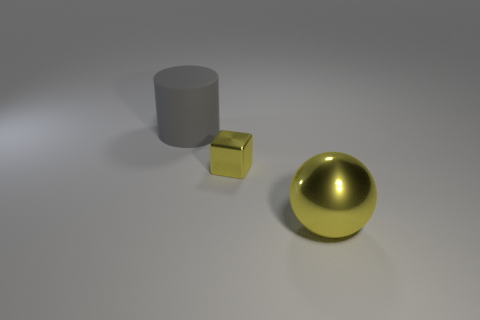Add 3 metallic cubes. How many objects exist? 6 Subtract all cubes. How many objects are left? 2 Subtract 0 brown spheres. How many objects are left? 3 Subtract all big gray shiny cylinders. Subtract all tiny blocks. How many objects are left? 2 Add 3 large shiny objects. How many large shiny objects are left? 4 Add 3 big yellow things. How many big yellow things exist? 4 